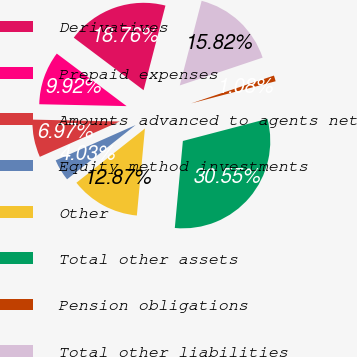Convert chart to OTSL. <chart><loc_0><loc_0><loc_500><loc_500><pie_chart><fcel>Derivatives<fcel>Prepaid expenses<fcel>Amounts advanced to agents net<fcel>Equity method investments<fcel>Other<fcel>Total other assets<fcel>Pension obligations<fcel>Total other liabilities<nl><fcel>18.76%<fcel>9.92%<fcel>6.97%<fcel>4.03%<fcel>12.87%<fcel>30.55%<fcel>1.08%<fcel>15.82%<nl></chart> 